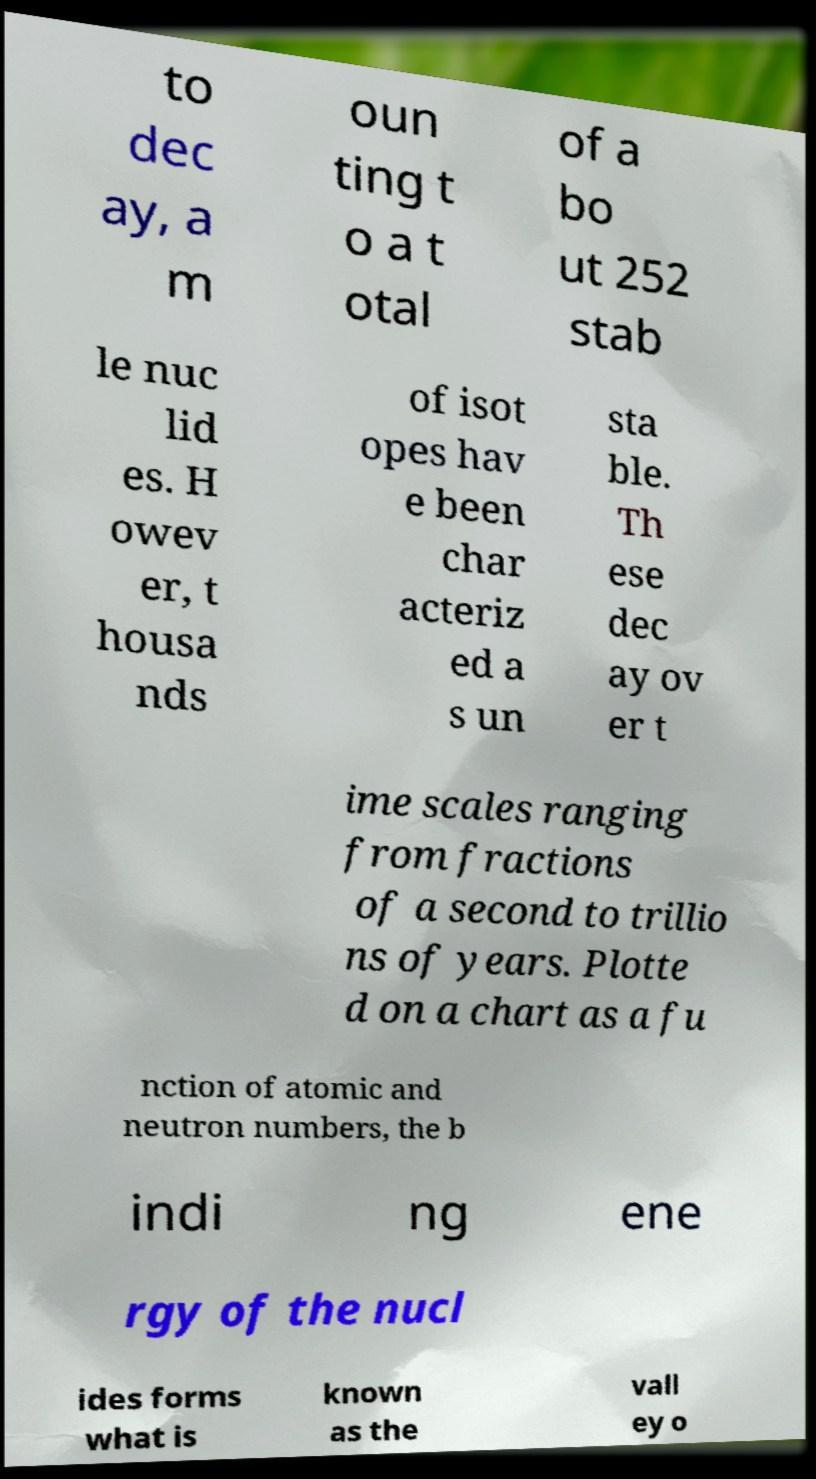Can you accurately transcribe the text from the provided image for me? to dec ay, a m oun ting t o a t otal of a bo ut 252 stab le nuc lid es. H owev er, t housa nds of isot opes hav e been char acteriz ed a s un sta ble. Th ese dec ay ov er t ime scales ranging from fractions of a second to trillio ns of years. Plotte d on a chart as a fu nction of atomic and neutron numbers, the b indi ng ene rgy of the nucl ides forms what is known as the vall ey o 